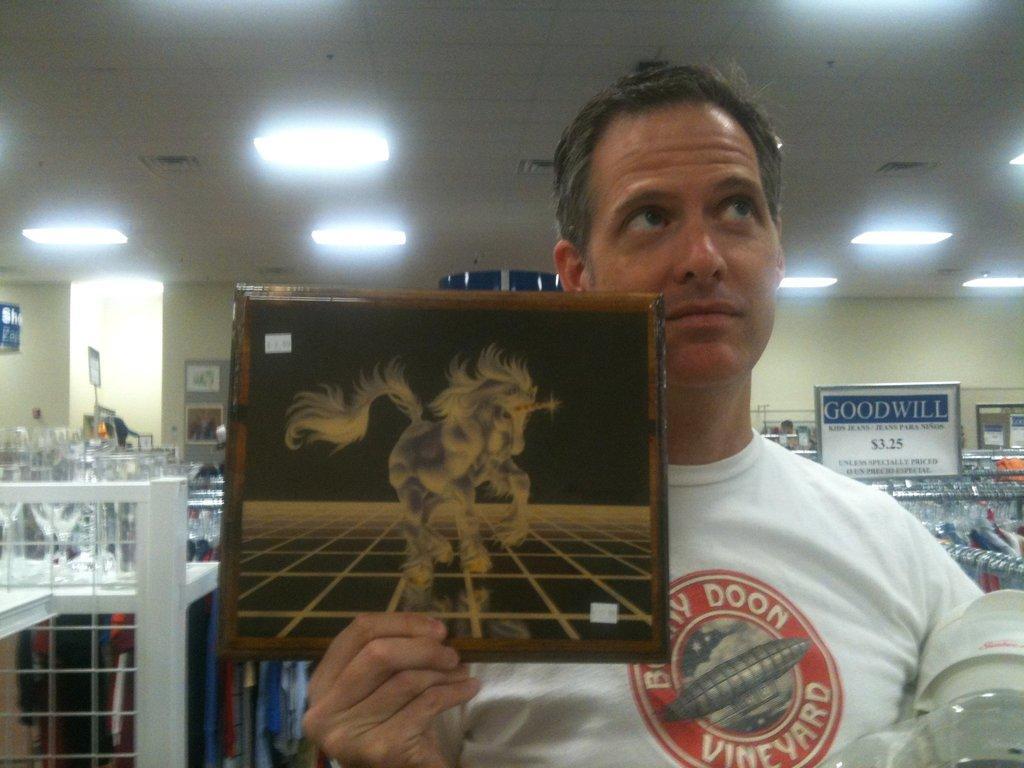Please provide a concise description of this image. In the picture I can see one person holding a board, back side we can see some tables and few objects are placed on it. 